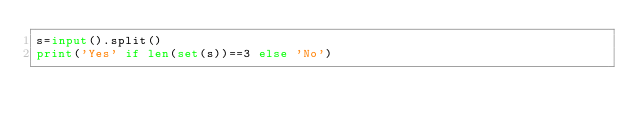<code> <loc_0><loc_0><loc_500><loc_500><_Python_>s=input().split()
print('Yes' if len(set(s))==3 else 'No')</code> 